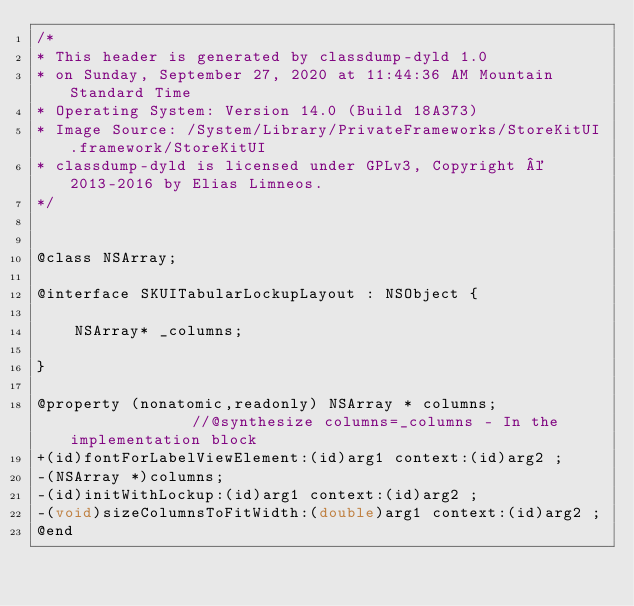Convert code to text. <code><loc_0><loc_0><loc_500><loc_500><_C_>/*
* This header is generated by classdump-dyld 1.0
* on Sunday, September 27, 2020 at 11:44:36 AM Mountain Standard Time
* Operating System: Version 14.0 (Build 18A373)
* Image Source: /System/Library/PrivateFrameworks/StoreKitUI.framework/StoreKitUI
* classdump-dyld is licensed under GPLv3, Copyright © 2013-2016 by Elias Limneos.
*/


@class NSArray;

@interface SKUITabularLockupLayout : NSObject {

	NSArray* _columns;

}

@property (nonatomic,readonly) NSArray * columns;              //@synthesize columns=_columns - In the implementation block
+(id)fontForLabelViewElement:(id)arg1 context:(id)arg2 ;
-(NSArray *)columns;
-(id)initWithLockup:(id)arg1 context:(id)arg2 ;
-(void)sizeColumnsToFitWidth:(double)arg1 context:(id)arg2 ;
@end

</code> 